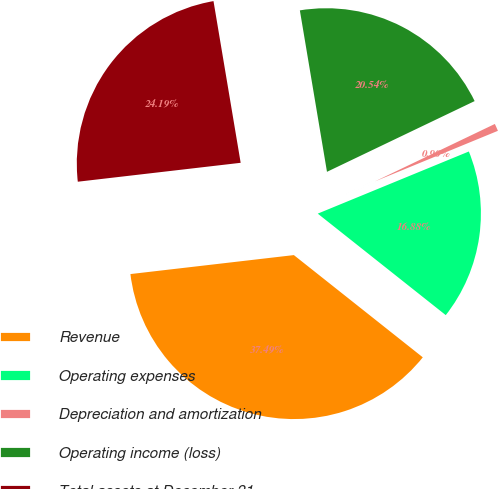<chart> <loc_0><loc_0><loc_500><loc_500><pie_chart><fcel>Revenue<fcel>Operating expenses<fcel>Depreciation and amortization<fcel>Operating income (loss)<fcel>Total assets at December 31<nl><fcel>37.49%<fcel>16.88%<fcel>0.9%<fcel>20.54%<fcel>24.19%<nl></chart> 